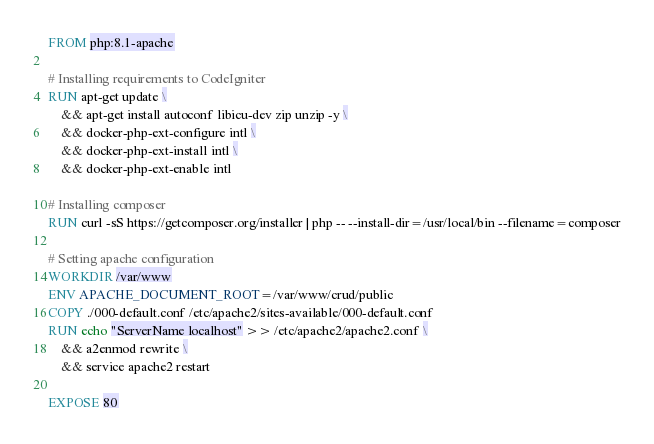<code> <loc_0><loc_0><loc_500><loc_500><_Dockerfile_>FROM php:8.1-apache

# Installing requirements to CodeIgniter
RUN apt-get update \
	&& apt-get install autoconf libicu-dev zip unzip -y \
	&& docker-php-ext-configure intl \
	&& docker-php-ext-install intl \
	&& docker-php-ext-enable intl 

# Installing composer
RUN curl -sS https://getcomposer.org/installer | php -- --install-dir=/usr/local/bin --filename=composer

# Setting apache configuration
WORKDIR /var/www
ENV APACHE_DOCUMENT_ROOT=/var/www/crud/public
COPY ./000-default.conf /etc/apache2/sites-available/000-default.conf
RUN echo "ServerName localhost" >> /etc/apache2/apache2.conf \
	&& a2enmod rewrite \
	&& service apache2 restart

EXPOSE 80

</code> 